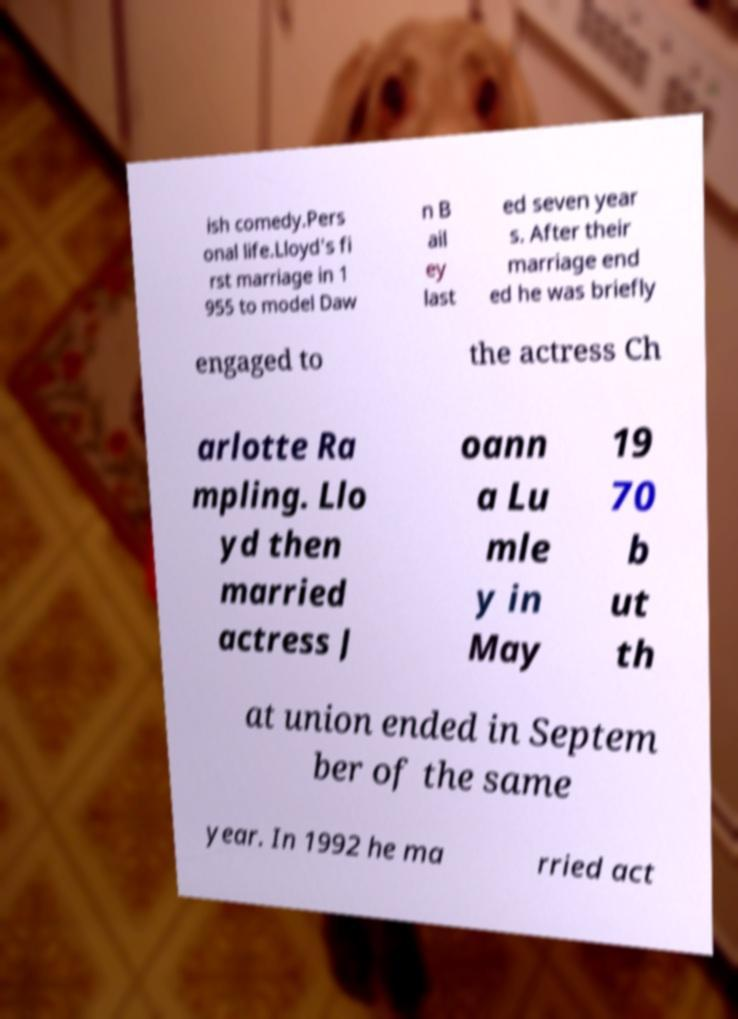For documentation purposes, I need the text within this image transcribed. Could you provide that? ish comedy.Pers onal life.Lloyd's fi rst marriage in 1 955 to model Daw n B ail ey last ed seven year s. After their marriage end ed he was briefly engaged to the actress Ch arlotte Ra mpling. Llo yd then married actress J oann a Lu mle y in May 19 70 b ut th at union ended in Septem ber of the same year. In 1992 he ma rried act 